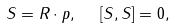<formula> <loc_0><loc_0><loc_500><loc_500>S = R \cdot p , \ \ [ S , S ] = 0 ,</formula> 